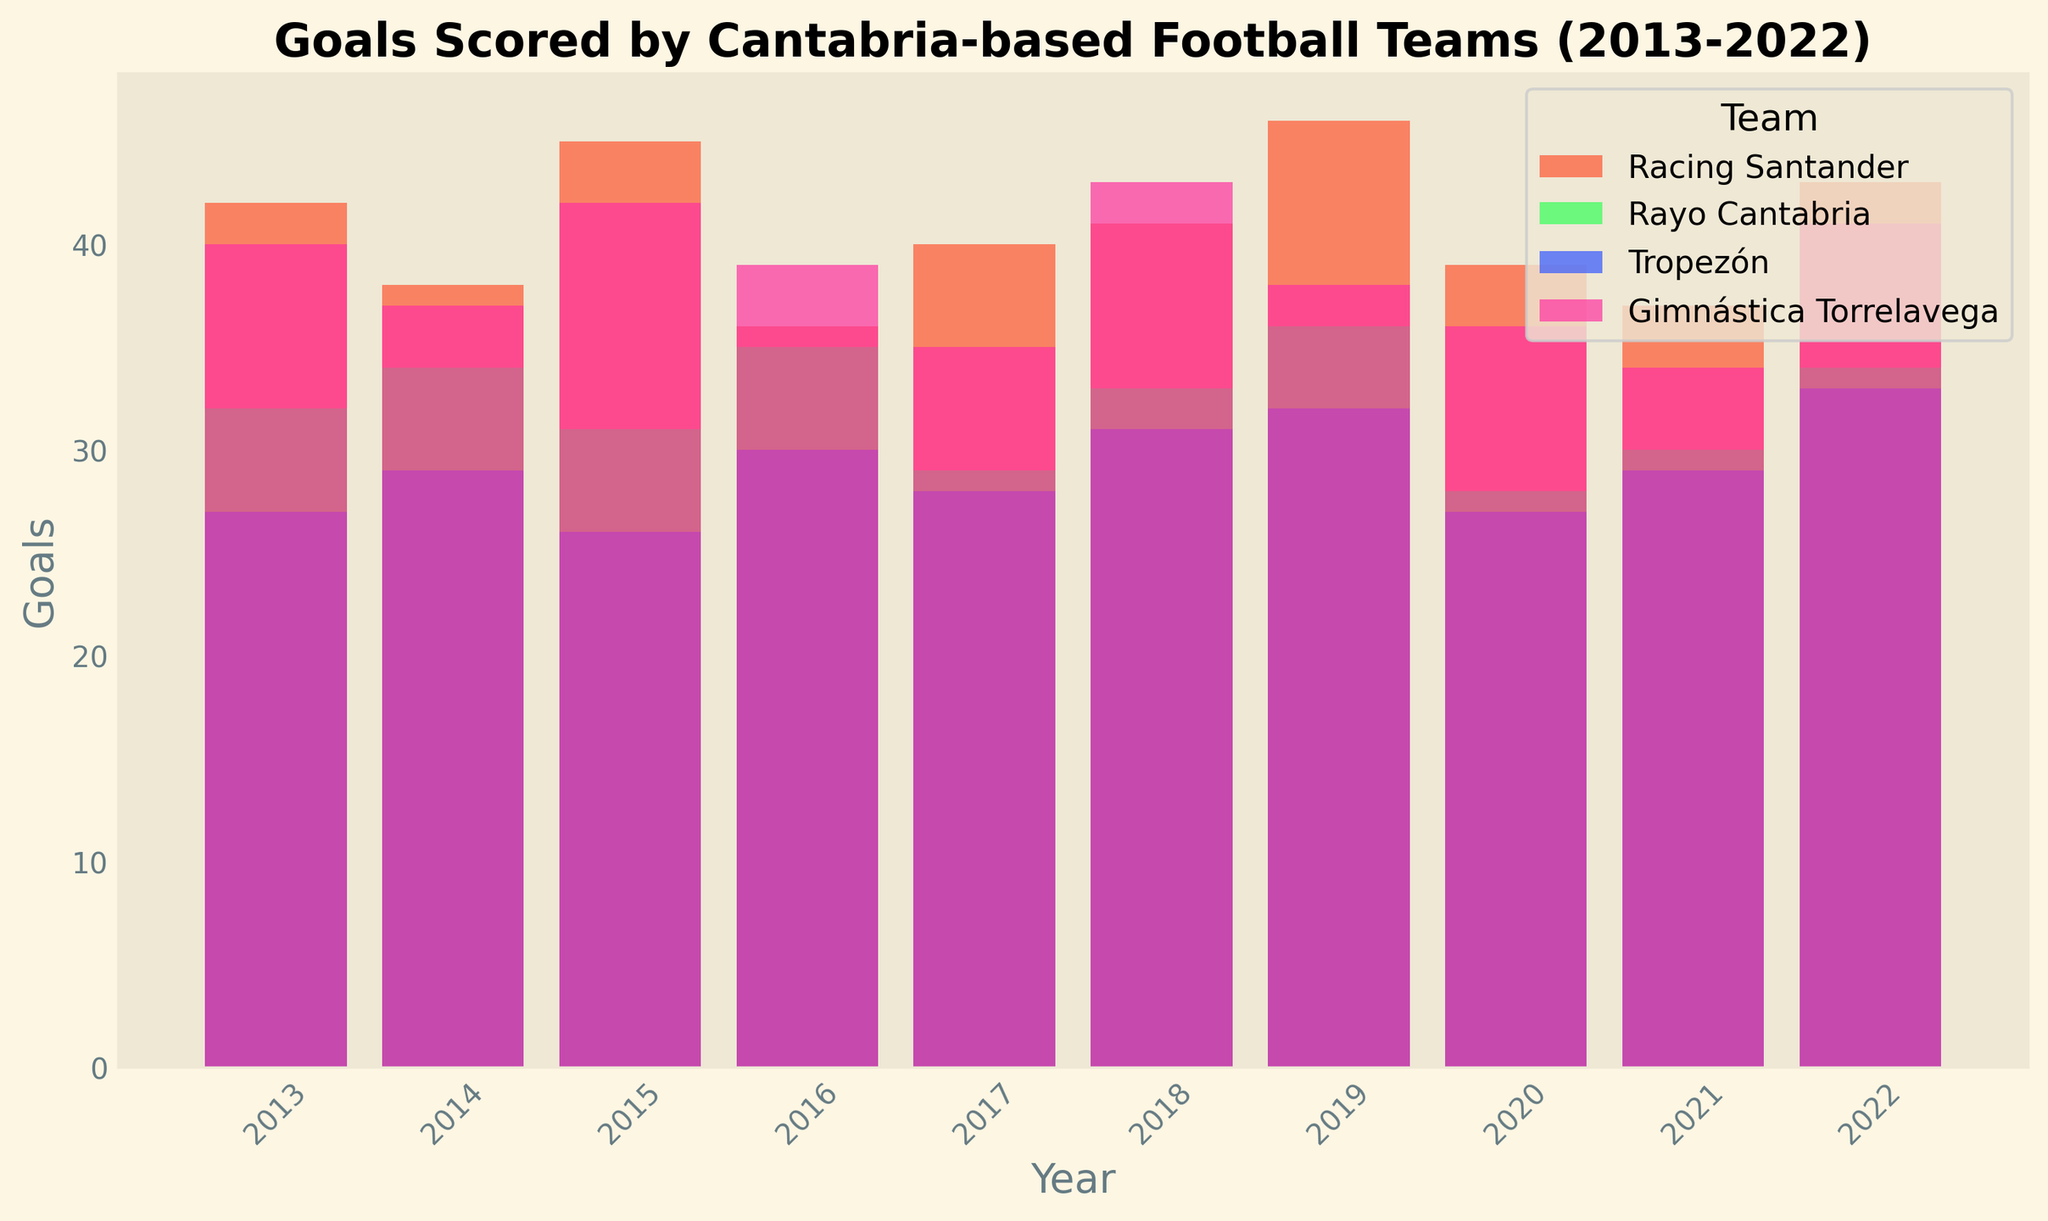Which team scored the most goals in 2022? Look at the bars for each team in 2022 and compare their heights. The tallest bar represents the team with the highest goals. Racing Santander's bar is the tallest.
Answer: Racing Santander Which team showed the most improvement in goals from 2013 to 2022? Calculate the difference between 2013 and 2022 for each team and compare the values. Racing Santander's increase from 42 to 43 is the highest compared to other teams.
Answer: Racing Santander How many total goals did Racing Santander score from 2013 to 2022? Sum the goals scored by Racing Santander for each year. 42 + 38 + 45 + 36 + 40 + 41 + 46 + 39 + 37 + 43 = 407
Answer: 407 Which year did Rayo Cantabria score the fewest goals? Examine Rayo Cantabria's bars and identify the shortest one. The shortest bar is in 2020.
Answer: 2020 Did any team score more than 45 goals in any single year between 2013 and 2022? Look at the height of bars for each team and check if any bar exceeds 45 goals. Racing Santander scored 46 goals in 2019.
Answer: Yes How many goals did Gimnástica Torrelavega score in 2018 compared to Tropezón the same year? Find the bars for Gimnástica Torrelavega and Tropezón in 2018 and compare their heights. Gimnástica Torrelavega scored 43 goals, and Tropezón scored 31 goals.
Answer: Gimnástica Torrelavega: 43, Tropezón: 31 Did the total number of goals scored by Tropezón increase or decrease from 2013 to 2022? Compare the goals scored by Tropezón in 2013 and 2022. Tropezón scored 27 goals in 2013 and 33 goals in 2022, indicating an increase.
Answer: Increase Which team had the most inconsistent goal scoring pattern from 2013 to 2022? Analyze the fluctuations in the bar heights for each team from year to year. Racing Santander has noticeable variations in their yearly goals, indicating inconsistency.
Answer: Racing Santander In which year did all teams combined score the most goals? Add the heights of the bars for all teams for each year and compare the totals. 2019 has the combination of the tallest bars across all teams.
Answer: 2019 